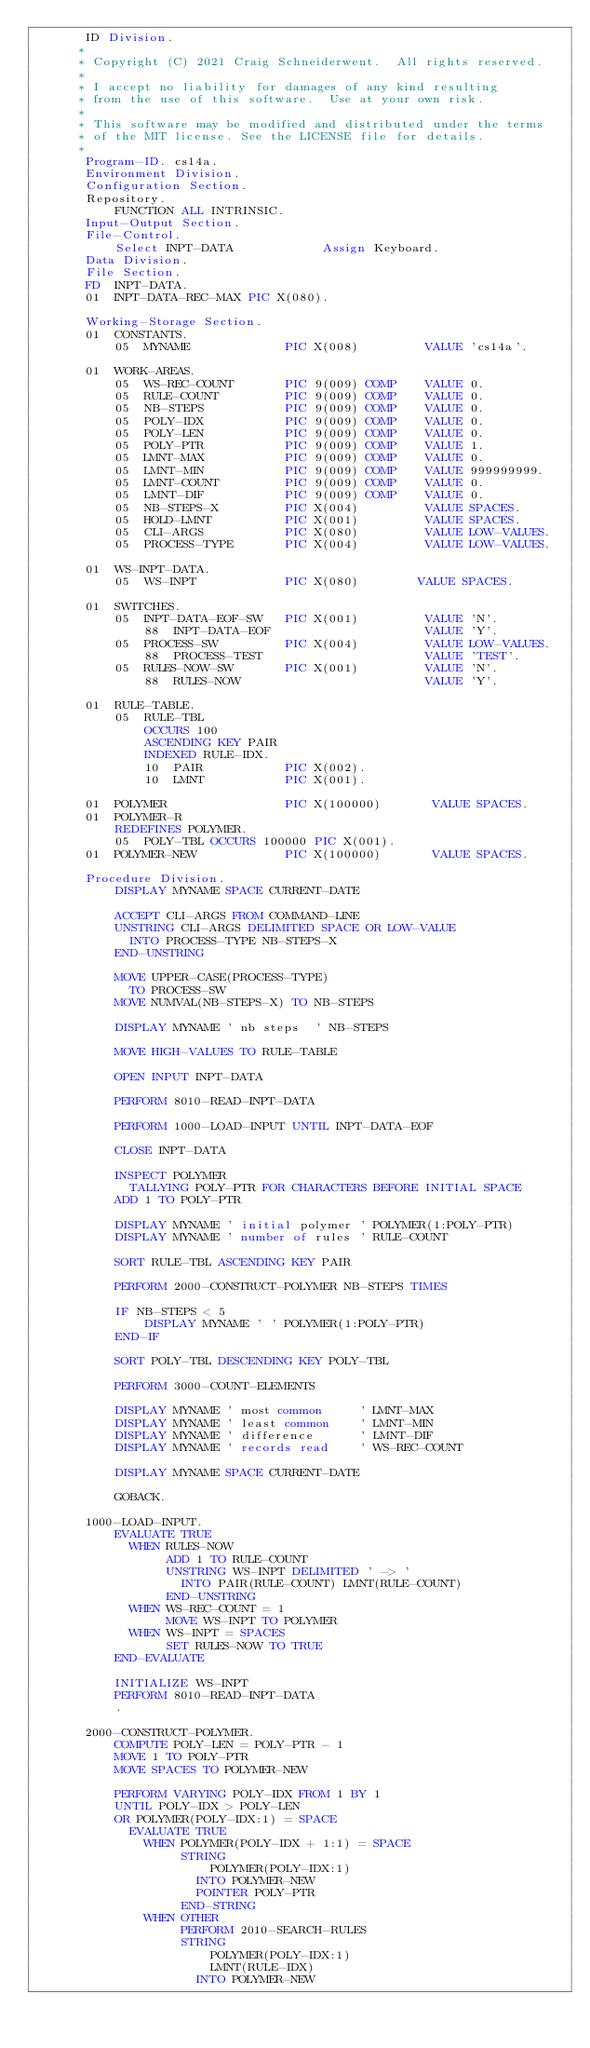Convert code to text. <code><loc_0><loc_0><loc_500><loc_500><_COBOL_>       ID Division.
      * 
      * Copyright (C) 2021 Craig Schneiderwent.  All rights reserved.
      * 
      * I accept no liability for damages of any kind resulting 
      * from the use of this software.  Use at your own risk.
      *
      * This software may be modified and distributed under the terms
      * of the MIT license. See the LICENSE file for details.
      *
       Program-ID. cs14a.
       Environment Division.
       Configuration Section.
       Repository.
           FUNCTION ALL INTRINSIC.
       Input-Output Section.
       File-Control.
           Select INPT-DATA            Assign Keyboard.
       Data Division.
       File Section.
       FD  INPT-DATA.
       01  INPT-DATA-REC-MAX PIC X(080).

       Working-Storage Section.
       01  CONSTANTS.
           05  MYNAME             PIC X(008)         VALUE 'cs14a'.

       01  WORK-AREAS.
           05  WS-REC-COUNT       PIC 9(009) COMP    VALUE 0.
           05  RULE-COUNT         PIC 9(009) COMP    VALUE 0.
           05  NB-STEPS           PIC 9(009) COMP    VALUE 0.
           05  POLY-IDX           PIC 9(009) COMP    VALUE 0.
           05  POLY-LEN           PIC 9(009) COMP    VALUE 0.
           05  POLY-PTR           PIC 9(009) COMP    VALUE 1.
           05  LMNT-MAX           PIC 9(009) COMP    VALUE 0.
           05  LMNT-MIN           PIC 9(009) COMP    VALUE 999999999.
           05  LMNT-COUNT         PIC 9(009) COMP    VALUE 0.
           05  LMNT-DIF           PIC 9(009) COMP    VALUE 0.
           05  NB-STEPS-X         PIC X(004)         VALUE SPACES.
           05  HOLD-LMNT          PIC X(001)         VALUE SPACES.
           05  CLI-ARGS           PIC X(080)         VALUE LOW-VALUES.
           05  PROCESS-TYPE       PIC X(004)         VALUE LOW-VALUES.

       01  WS-INPT-DATA.
           05  WS-INPT            PIC X(080)        VALUE SPACES.

       01  SWITCHES.
           05  INPT-DATA-EOF-SW   PIC X(001)         VALUE 'N'.
               88  INPT-DATA-EOF                     VALUE 'Y'.
           05  PROCESS-SW         PIC X(004)         VALUE LOW-VALUES.
               88  PROCESS-TEST                      VALUE 'TEST'.
           05  RULES-NOW-SW       PIC X(001)         VALUE 'N'.
               88  RULES-NOW                         VALUE 'Y'.

       01  RULE-TABLE.
           05  RULE-TBL
               OCCURS 100
               ASCENDING KEY PAIR
               INDEXED RULE-IDX.
               10  PAIR           PIC X(002).
               10  LMNT           PIC X(001).

       01  POLYMER                PIC X(100000)       VALUE SPACES.
       01  POLYMER-R
           REDEFINES POLYMER.
           05  POLY-TBL OCCURS 100000 PIC X(001).
       01  POLYMER-NEW            PIC X(100000)       VALUE SPACES.

       Procedure Division.
           DISPLAY MYNAME SPACE CURRENT-DATE

           ACCEPT CLI-ARGS FROM COMMAND-LINE
           UNSTRING CLI-ARGS DELIMITED SPACE OR LOW-VALUE
             INTO PROCESS-TYPE NB-STEPS-X
           END-UNSTRING

           MOVE UPPER-CASE(PROCESS-TYPE)
             TO PROCESS-SW
           MOVE NUMVAL(NB-STEPS-X) TO NB-STEPS

           DISPLAY MYNAME ' nb steps  ' NB-STEPS

           MOVE HIGH-VALUES TO RULE-TABLE

           OPEN INPUT INPT-DATA

           PERFORM 8010-READ-INPT-DATA

           PERFORM 1000-LOAD-INPUT UNTIL INPT-DATA-EOF

           CLOSE INPT-DATA

           INSPECT POLYMER
             TALLYING POLY-PTR FOR CHARACTERS BEFORE INITIAL SPACE
           ADD 1 TO POLY-PTR

           DISPLAY MYNAME ' initial polymer ' POLYMER(1:POLY-PTR)
           DISPLAY MYNAME ' number of rules ' RULE-COUNT

           SORT RULE-TBL ASCENDING KEY PAIR

           PERFORM 2000-CONSTRUCT-POLYMER NB-STEPS TIMES

           IF NB-STEPS < 5
               DISPLAY MYNAME ' ' POLYMER(1:POLY-PTR)
           END-IF

           SORT POLY-TBL DESCENDING KEY POLY-TBL

           PERFORM 3000-COUNT-ELEMENTS

           DISPLAY MYNAME ' most common     ' LMNT-MAX
           DISPLAY MYNAME ' least common    ' LMNT-MIN
           DISPLAY MYNAME ' difference      ' LMNT-DIF
           DISPLAY MYNAME ' records read    ' WS-REC-COUNT

           DISPLAY MYNAME SPACE CURRENT-DATE

           GOBACK.

       1000-LOAD-INPUT.
           EVALUATE TRUE
             WHEN RULES-NOW
                  ADD 1 TO RULE-COUNT
                  UNSTRING WS-INPT DELIMITED ' -> '
                    INTO PAIR(RULE-COUNT) LMNT(RULE-COUNT)
                  END-UNSTRING
             WHEN WS-REC-COUNT = 1
                  MOVE WS-INPT TO POLYMER
             WHEN WS-INPT = SPACES
                  SET RULES-NOW TO TRUE
           END-EVALUATE

           INITIALIZE WS-INPT
           PERFORM 8010-READ-INPT-DATA
           .

       2000-CONSTRUCT-POLYMER.
           COMPUTE POLY-LEN = POLY-PTR - 1
           MOVE 1 TO POLY-PTR
           MOVE SPACES TO POLYMER-NEW

           PERFORM VARYING POLY-IDX FROM 1 BY 1
           UNTIL POLY-IDX > POLY-LEN
           OR POLYMER(POLY-IDX:1) = SPACE
             EVALUATE TRUE
               WHEN POLYMER(POLY-IDX + 1:1) = SPACE
                    STRING
                        POLYMER(POLY-IDX:1)
                      INTO POLYMER-NEW
                      POINTER POLY-PTR
                    END-STRING
               WHEN OTHER
                    PERFORM 2010-SEARCH-RULES
                    STRING
                        POLYMER(POLY-IDX:1)
                        LMNT(RULE-IDX)
                      INTO POLYMER-NEW</code> 